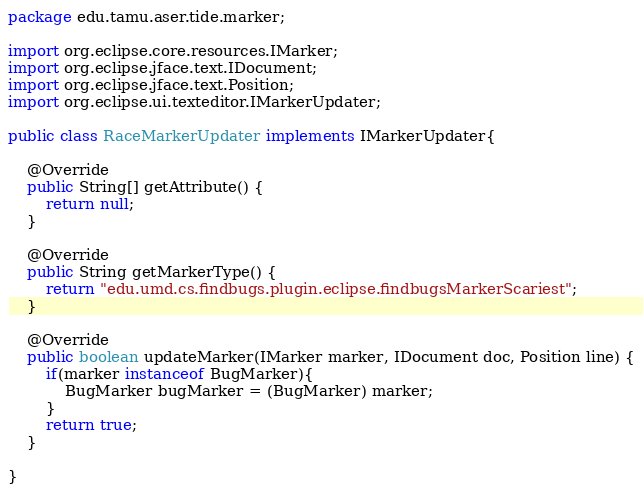<code> <loc_0><loc_0><loc_500><loc_500><_Java_>package edu.tamu.aser.tide.marker;

import org.eclipse.core.resources.IMarker;
import org.eclipse.jface.text.IDocument;
import org.eclipse.jface.text.Position;
import org.eclipse.ui.texteditor.IMarkerUpdater;

public class RaceMarkerUpdater implements IMarkerUpdater{

	@Override
	public String[] getAttribute() {
		return null;
	}

	@Override
	public String getMarkerType() {
		return "edu.umd.cs.findbugs.plugin.eclipse.findbugsMarkerScariest";
	}

	@Override
	public boolean updateMarker(IMarker marker, IDocument doc, Position line) {
		if(marker instanceof BugMarker){
			BugMarker bugMarker = (BugMarker) marker;
		}
		return true;
	}

}
</code> 